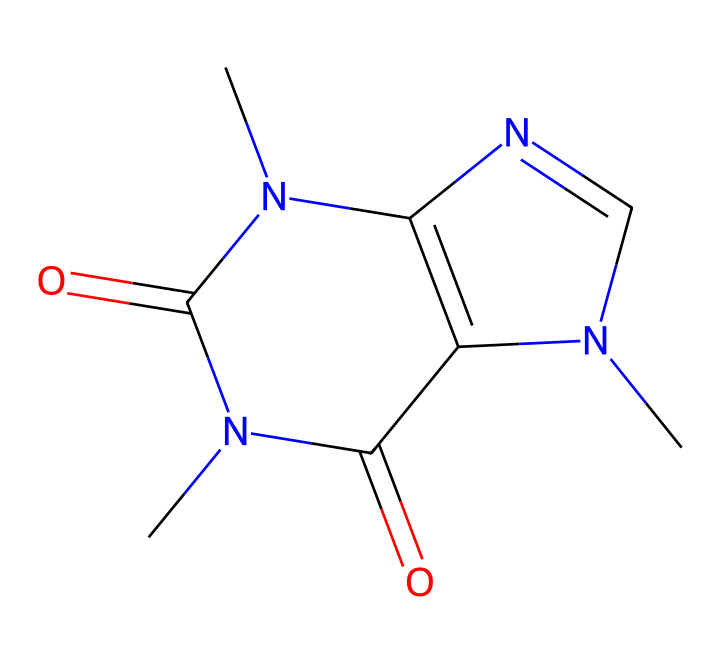What is the molecular formula of caffeine? To find the molecular formula, count the number of each type of atom present in the chemical structure. The provided SMILES representation indicates the presence of carbon (C), hydrogen (H), nitrogen (N), and oxygen (O) atoms. After analyzing the structure, we find there are 8 carbon atoms, 10 hydrogen atoms, 4 nitrogen atoms, and 2 oxygen atoms, resulting in the molecular formula C8H10N4O2.
Answer: C8H10N4O2 How many nitrogen atoms are in the caffeine structure? By interpreting the SMILES representation, we can count the nitrogen (N) atoms specifically. The structure shows 4 distinct nitrogen atoms throughout various rings and functional groups. Therefore, the answer is the total count of these nitrogen atoms.
Answer: 4 What type of compound is caffeine classified as? Based on the functional groups and the overall structure derived from the SMILES, caffeine can be classified as a methylxanthine. This classification is based on the structure comprising a xanthine backbone with methyl groups attached.
Answer: methylxanthine What functional groups are present in caffeine? Analyzing the structure reveals the presence of amine (due to nitrogen atoms), carbonyl (due to the carbon-oxygen double bonds), and methyl groups (the CH3 groups). By identifying these groups, we can state the functional groups present in caffeine.
Answer: amine, carbonyl, methyl How many rings are present in the caffeine molecule? The SMILES structure can be analyzed to determine the number of rings. By examining the connectivity of atoms, we can identify two fused rings that characterize caffeine's bicyclic structure. Counting these, the number of rings can be concluded.
Answer: 2 What is the primary medicinal use of caffeine? Caffeine is primarily used as a central nervous system stimulant, which helps to increase alertness and combat fatigue. This is a well-known effect of caffeine supported by its pharmacological properties.
Answer: stimulant 